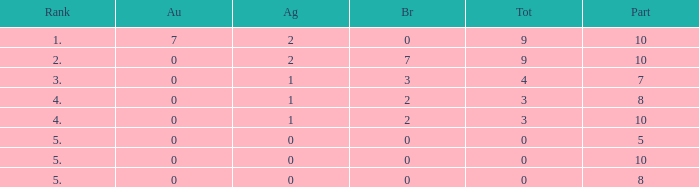What is the total number of Participants that has Silver that's smaller than 0? None. 